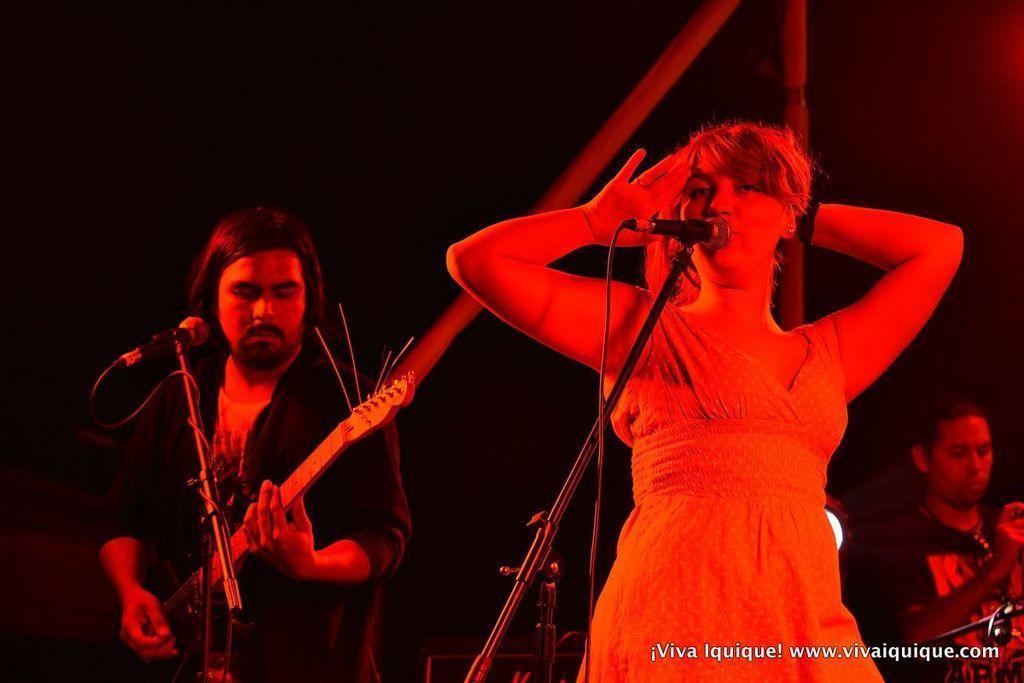Could you give a brief overview of what you see in this image? Here we can see a man and a woman. They are singing on the mike. And he is playing guitar. 